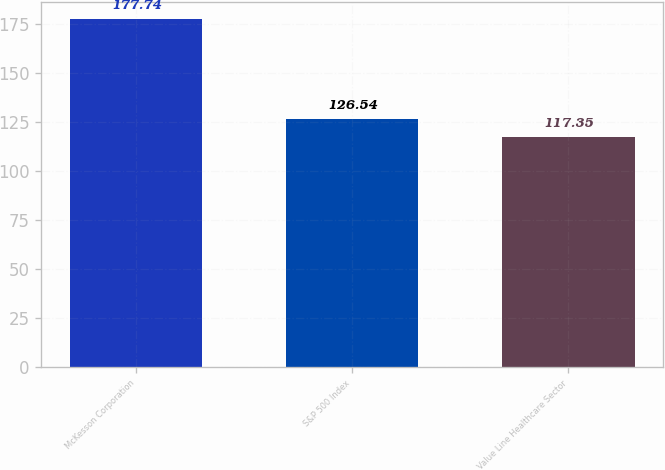<chart> <loc_0><loc_0><loc_500><loc_500><bar_chart><fcel>McKesson Corporation<fcel>S&P 500 Index<fcel>Value Line Healthcare Sector<nl><fcel>177.74<fcel>126.54<fcel>117.35<nl></chart> 